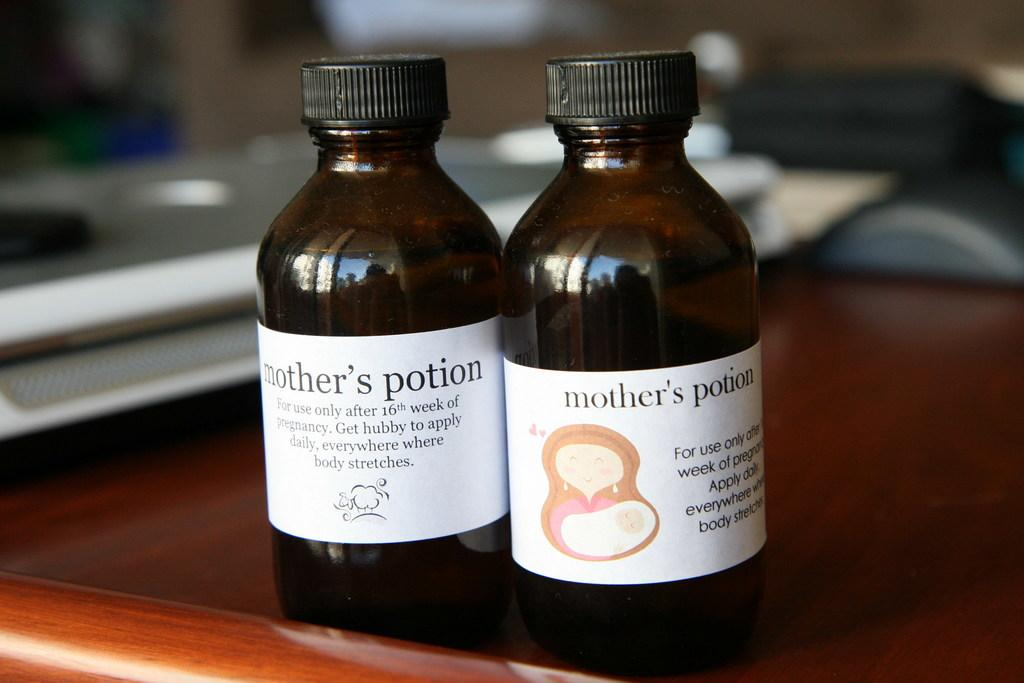<image>
Offer a succinct explanation of the picture presented. Two small bottle of Mother's potion made to be applied to pregnant women's bodies to prevent stretch marks. 